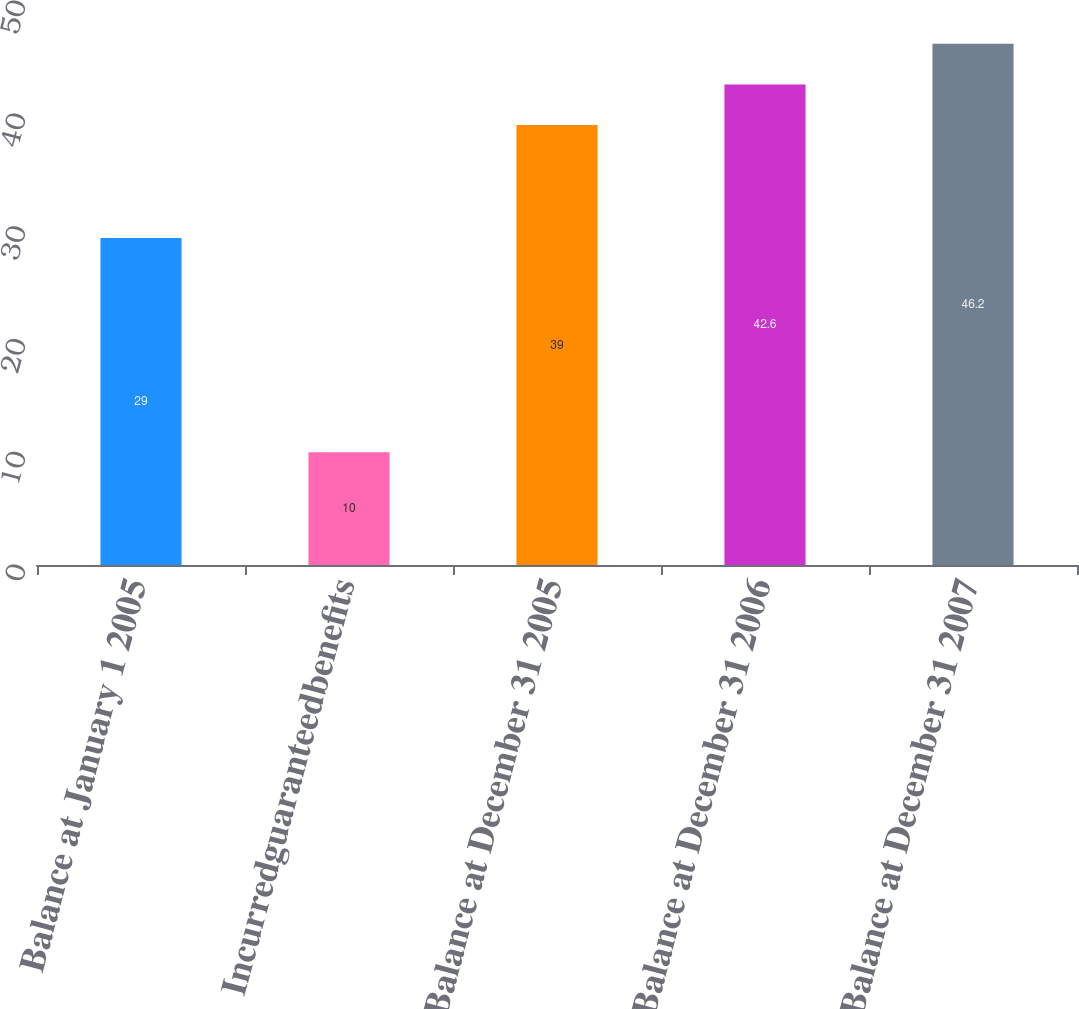Convert chart. <chart><loc_0><loc_0><loc_500><loc_500><bar_chart><fcel>Balance at January 1 2005<fcel>Incurredguaranteedbenefits<fcel>Balance at December 31 2005<fcel>Balance at December 31 2006<fcel>Balance at December 31 2007<nl><fcel>29<fcel>10<fcel>39<fcel>42.6<fcel>46.2<nl></chart> 